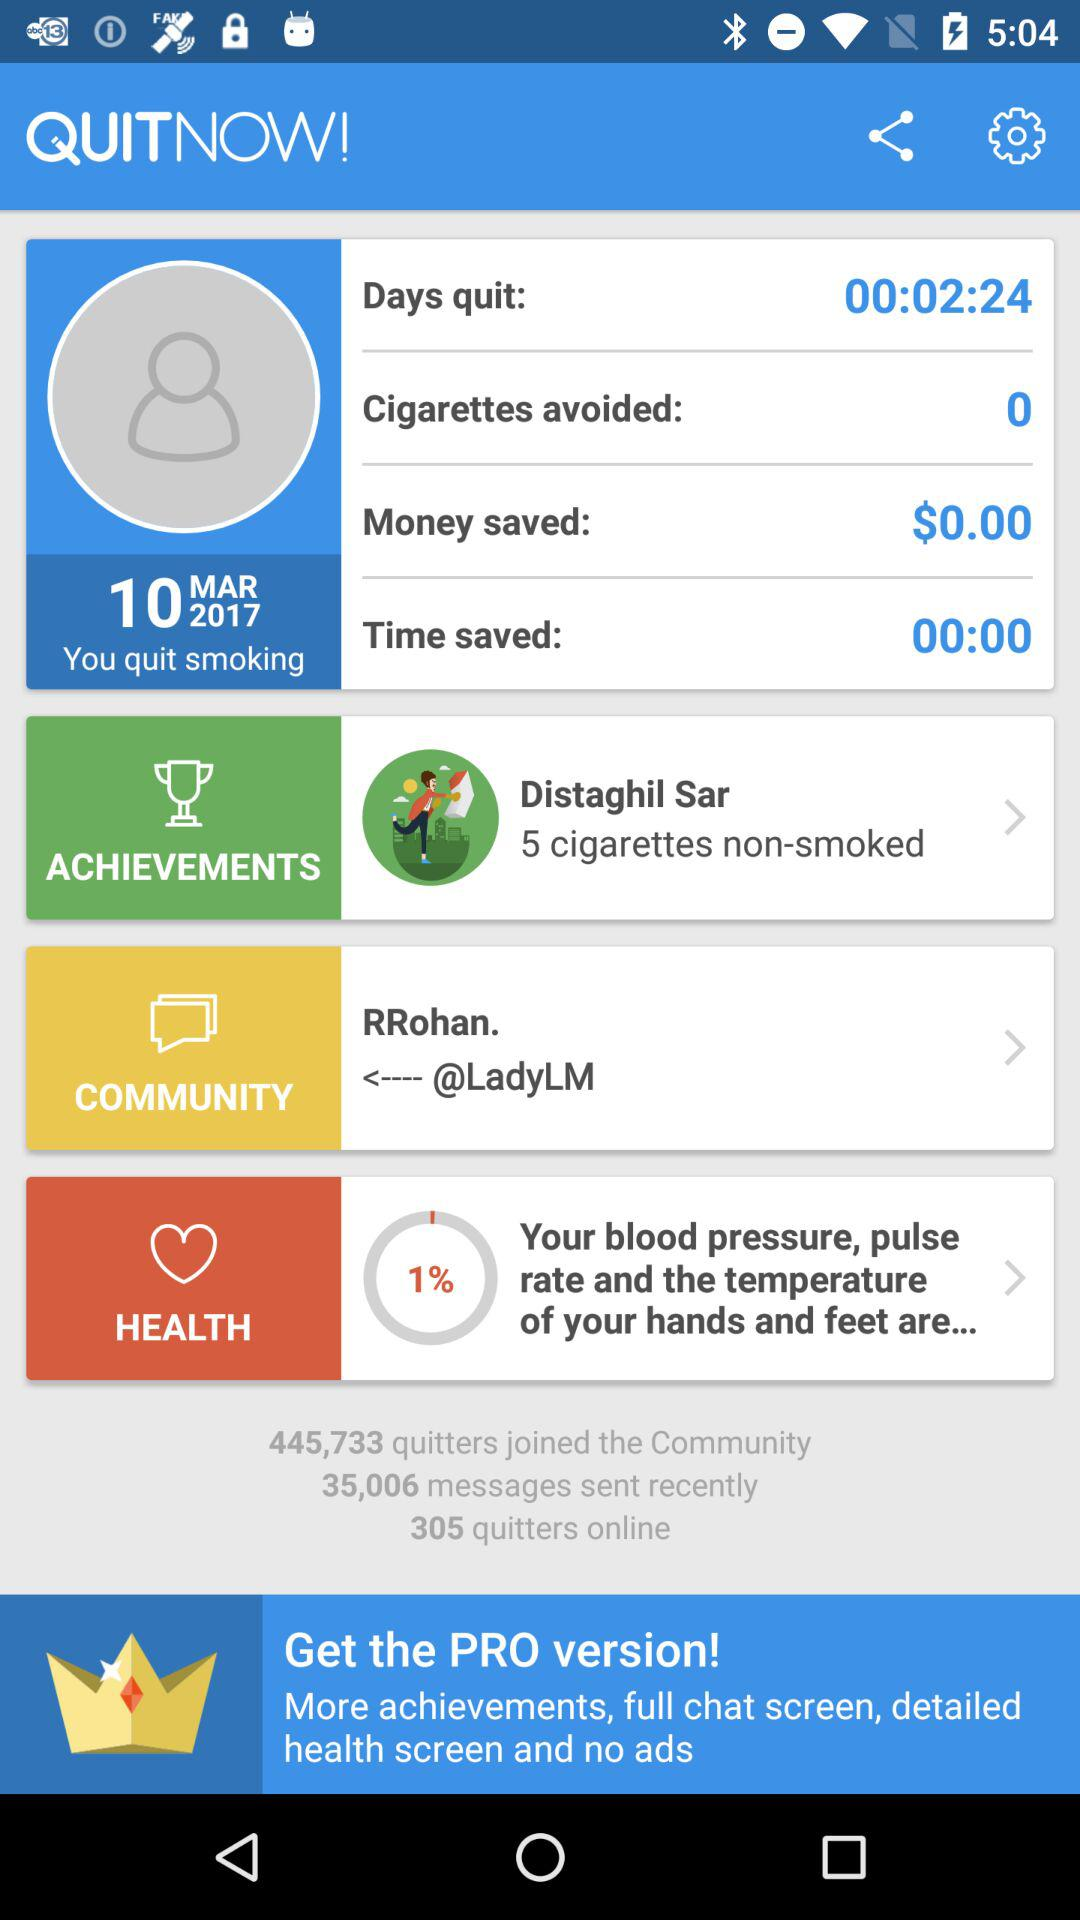What's the avoided number of cigarettes? The avoided number of cigarettes is 0. 